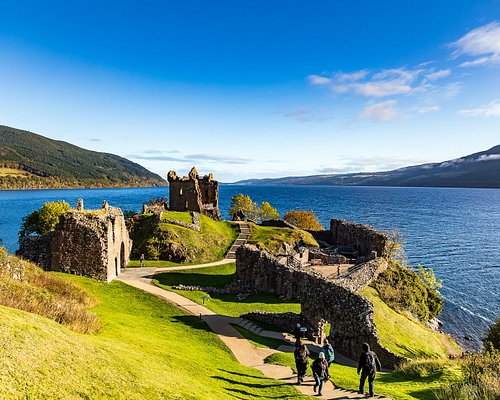What would it be like to visit the castle at night? Visiting Urquhart Castle at night would be a hauntingly beautiful experience. Under the moonlit sky, the silhouette of the ruins would stand stark against the shimmering waters of Loch Ness. The castle's weathered stones, bathed in the soft glow of moonlight, would exude an ethereal, almost otherworldly atmosphere. The sounds of the loch gently lapping against the shore and the rustle of the wind through the trees would add to the serene, yet eerie ambiance. If you believe in legends, you might even imagine spotting Nessie, the mythical Loch Ness Monster, making a nighttime appearance in the loch. 